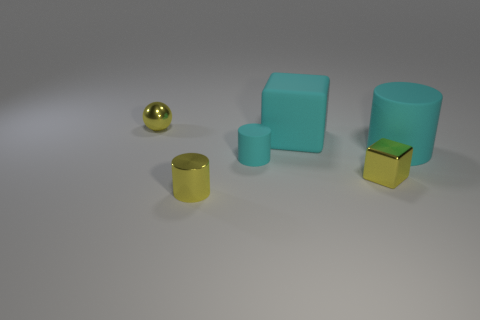Do the object that is behind the cyan block and the small yellow object on the right side of the large block have the same material?
Give a very brief answer. Yes. What number of tiny objects are red cylinders or shiny things?
Ensure brevity in your answer.  3. There is a big cyan thing that is made of the same material as the large cylinder; what shape is it?
Provide a short and direct response. Cube. Is the number of small cyan things that are on the left side of the small yellow metallic sphere less than the number of tiny yellow cylinders?
Offer a terse response. Yes. How many rubber objects are blocks or cyan cylinders?
Provide a short and direct response. 3. Are there any cyan matte cubes of the same size as the yellow shiny cube?
Ensure brevity in your answer.  No. The big thing that is the same color as the big cylinder is what shape?
Keep it short and to the point. Cube. What number of brown metal cylinders have the same size as the cyan rubber block?
Your answer should be compact. 0. There is a yellow metal object that is behind the tiny cyan rubber thing; is its size the same as the cyan object that is in front of the large cylinder?
Keep it short and to the point. Yes. How many things are either small purple cylinders or objects that are on the right side of the small sphere?
Provide a short and direct response. 5. 